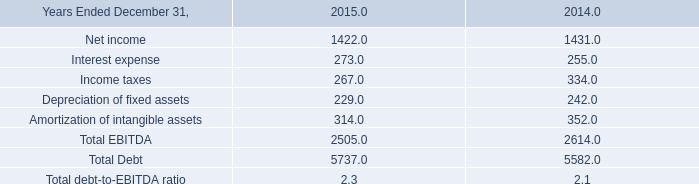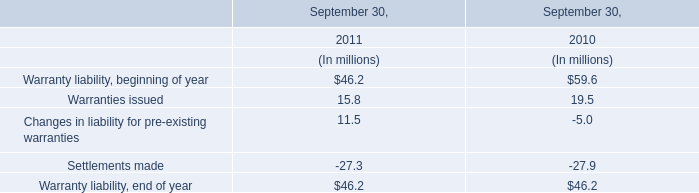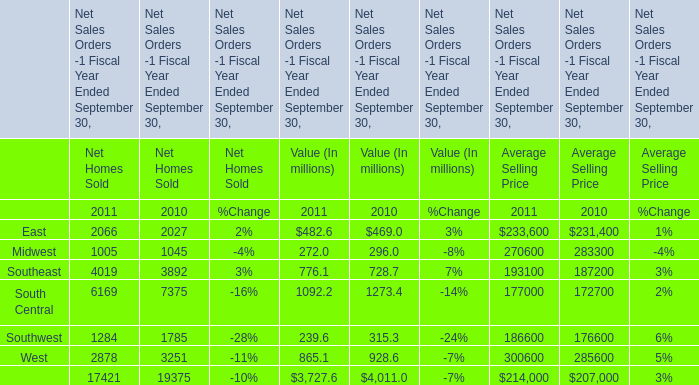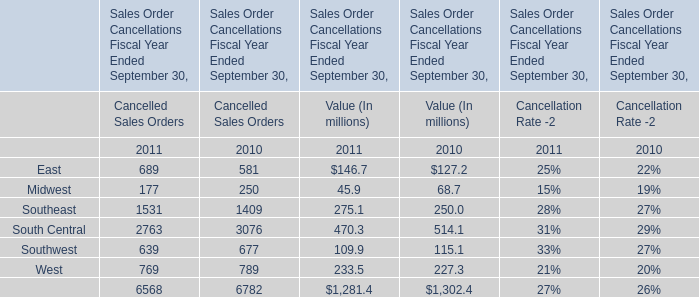In which years is East greater than Midwest (for Value (In millions))? 
Answer: 2010; 2011. 